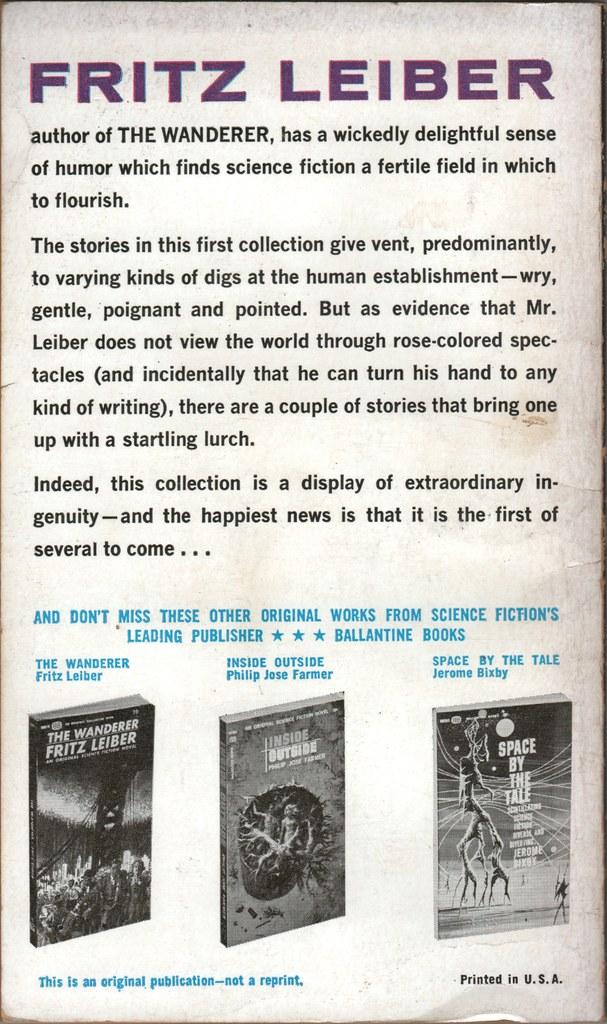What author is being discussed?
Your answer should be compact. Fritz leiber. 